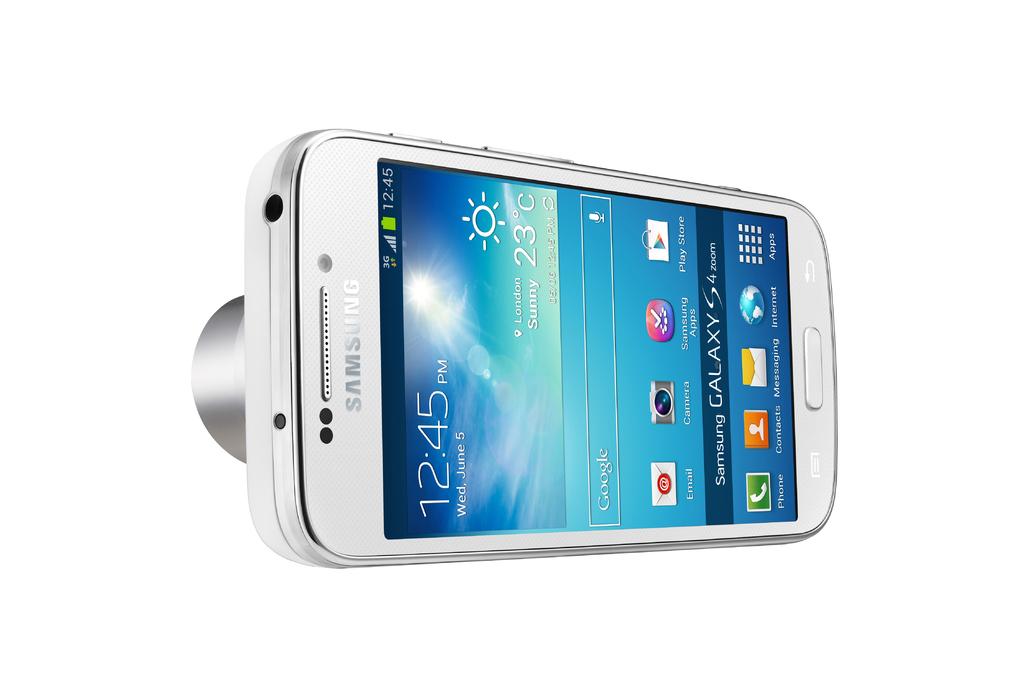What apps are on this phone?
Give a very brief answer. Email, camera, samsung apps, play store, phone, contacts, messaging, internet, apps. What time does the phone say it is?
Give a very brief answer. 12:45. 